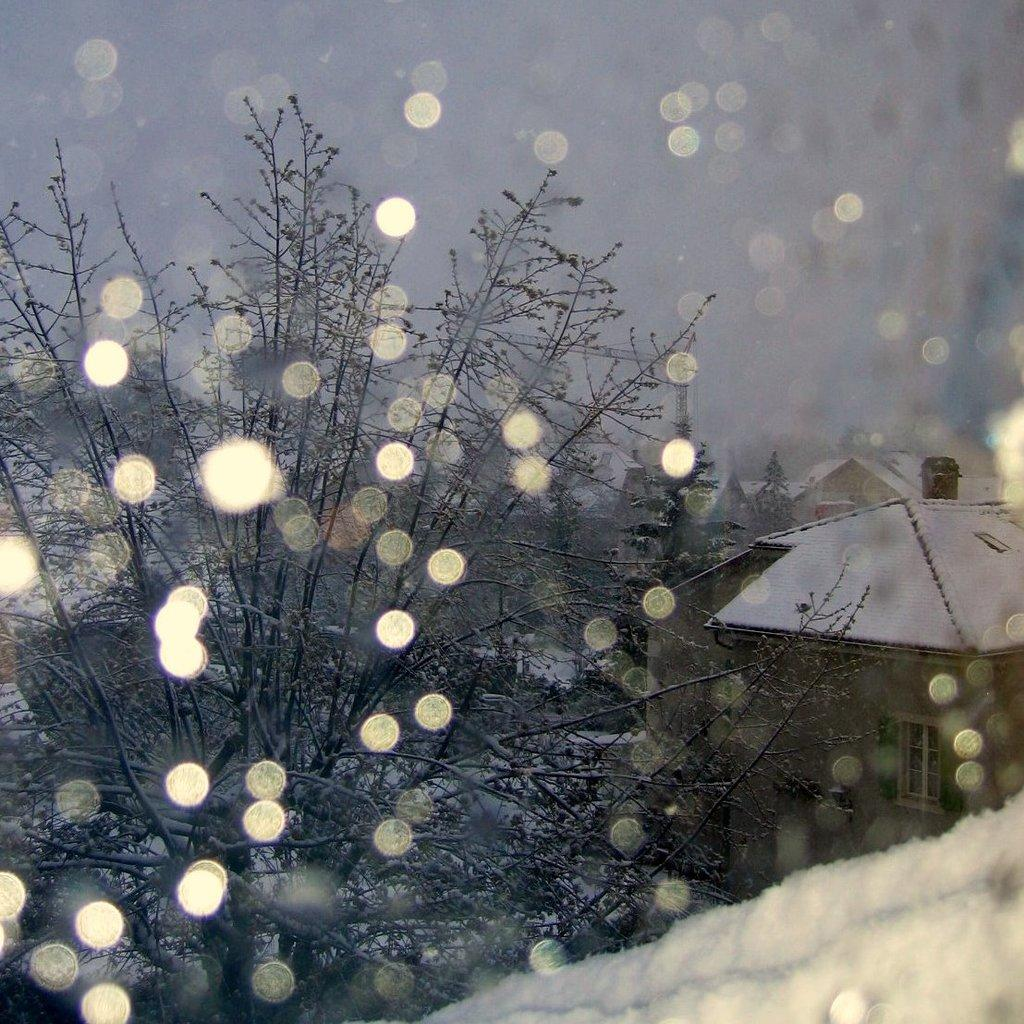What type of weather is depicted in the image? There is snow in the image, indicating a winter scene. What natural elements can be seen in the image? There are trees in the image. What man-made structures are present in the image? There are houses in the image. What is visible in the background of the image? The sky is visible in the background of the image, and it is clear. What type of poison is being used to shame the cent in the image? There is no cent or poison present in the image. The image features snow, trees, houses, and a clear sky. 